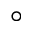<formula> <loc_0><loc_0><loc_500><loc_500>^ { \circ }</formula> 